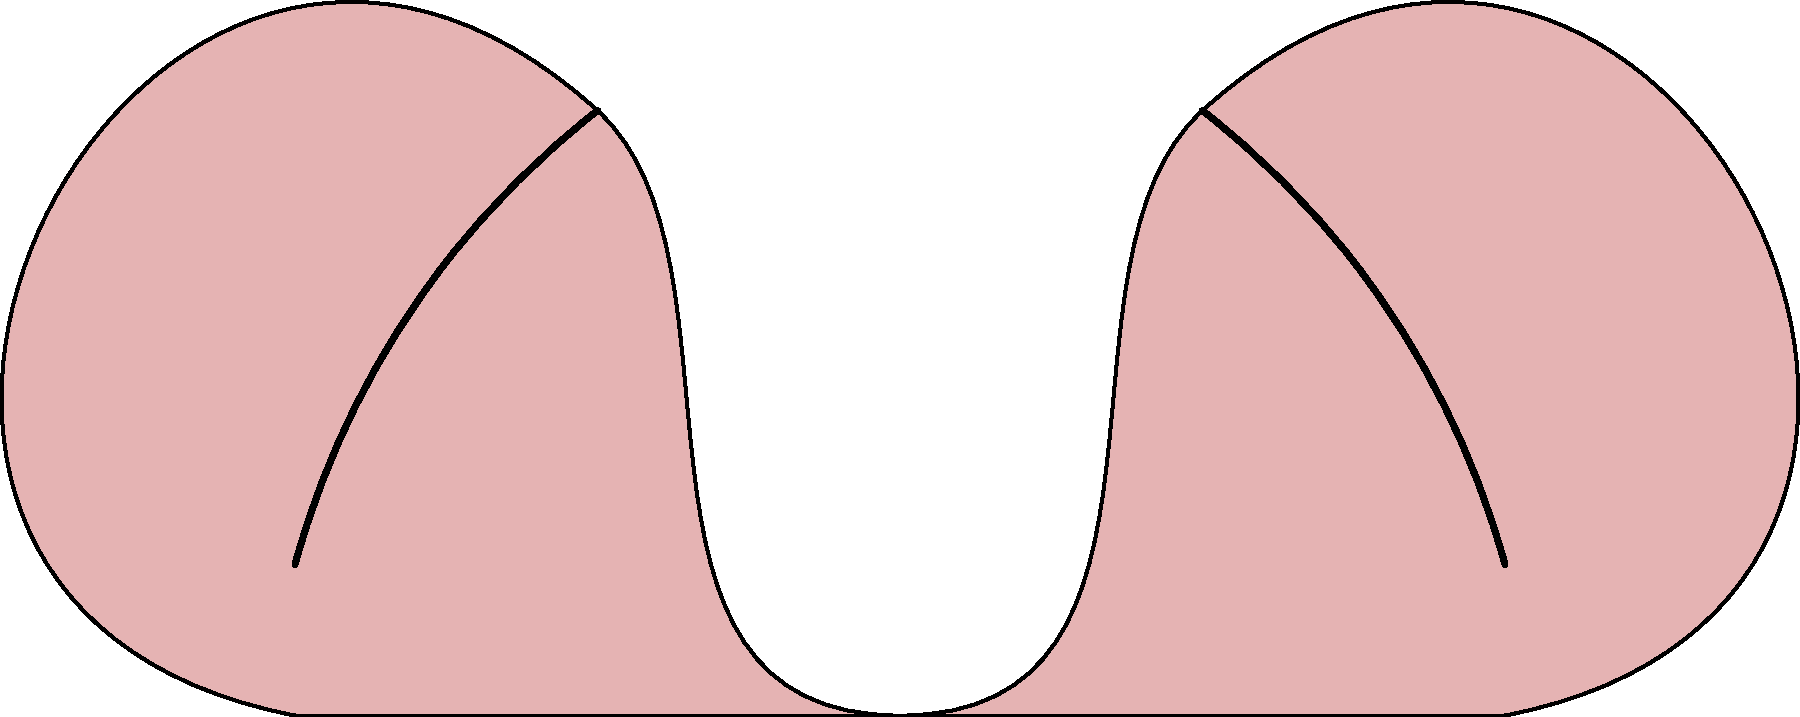In the labeled cross-section diagram of the female reproductive system, which structure is most likely to be affected in cases of endometriosis, a condition often associated with infertility? Explain your reasoning based on the anatomy shown. To answer this question, let's analyze each labeled structure and its relevance to endometriosis:

1. Structure A: This is the main body of the uterus, where the endometrium (uterine lining) is located. Endometriosis occurs when endometrial-like tissue grows outside the uterus.

2. Structure B: These are the ovaries, which produce eggs and hormones. While endometriosis can affect ovaries (forming ovarian cysts), it's not the primary site.

3. Structure C: These are the fallopian tubes, which transport eggs from the ovaries to the uterus. Endometriosis can affect the fallopian tubes, but it's not the most common site.

4. Structure D: This is the cervix, which connects the uterus to the vagina. Endometriosis rarely affects the cervix.

5. Structure E: This represents the endometrium, the inner lining of the uterus. In endometriosis, tissue similar to the endometrium grows outside the uterus.

Endometriosis most commonly affects the pelvic peritoneum, ovaries, and fallopian tubes. However, the condition is defined by the presence of endometrial-like tissue outside its normal location.

Given the options in the diagram, Structure E (the endometrium) is most directly related to endometriosis. While the condition involves tissue growing outside this area, the endometrium itself is the tissue type that defines the condition.
Answer: Structure E (endometrium) 